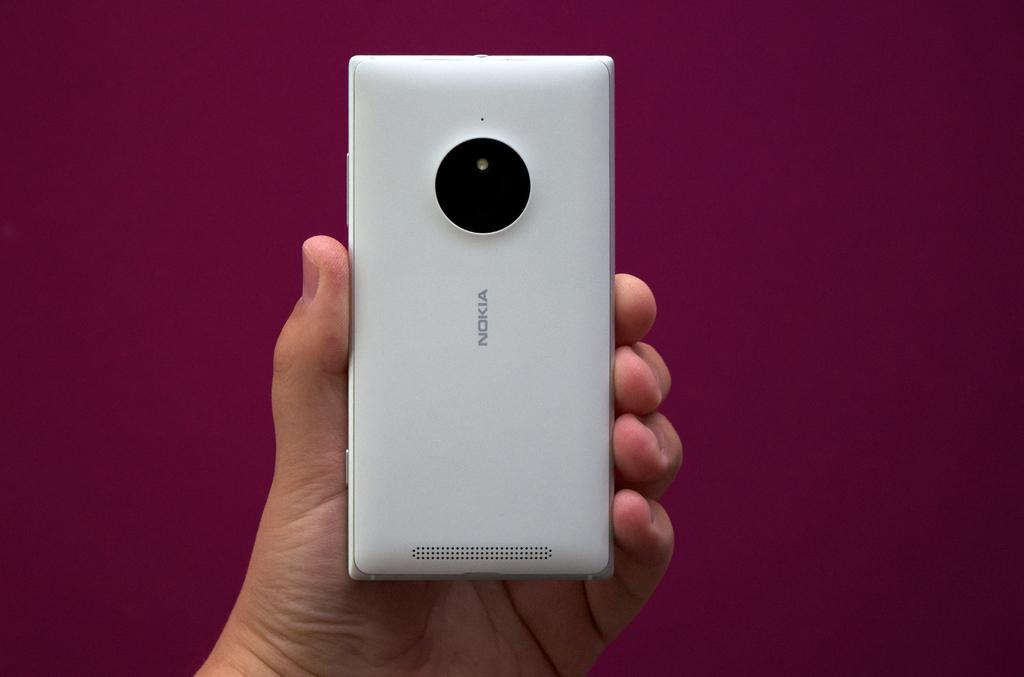<image>
Offer a succinct explanation of the picture presented. A person holding a nokia smart phone in their hand. 